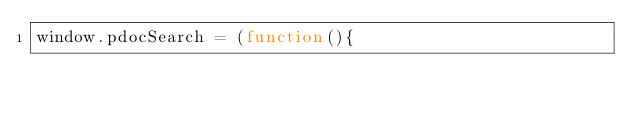<code> <loc_0><loc_0><loc_500><loc_500><_JavaScript_>window.pdocSearch = (function(){</code> 